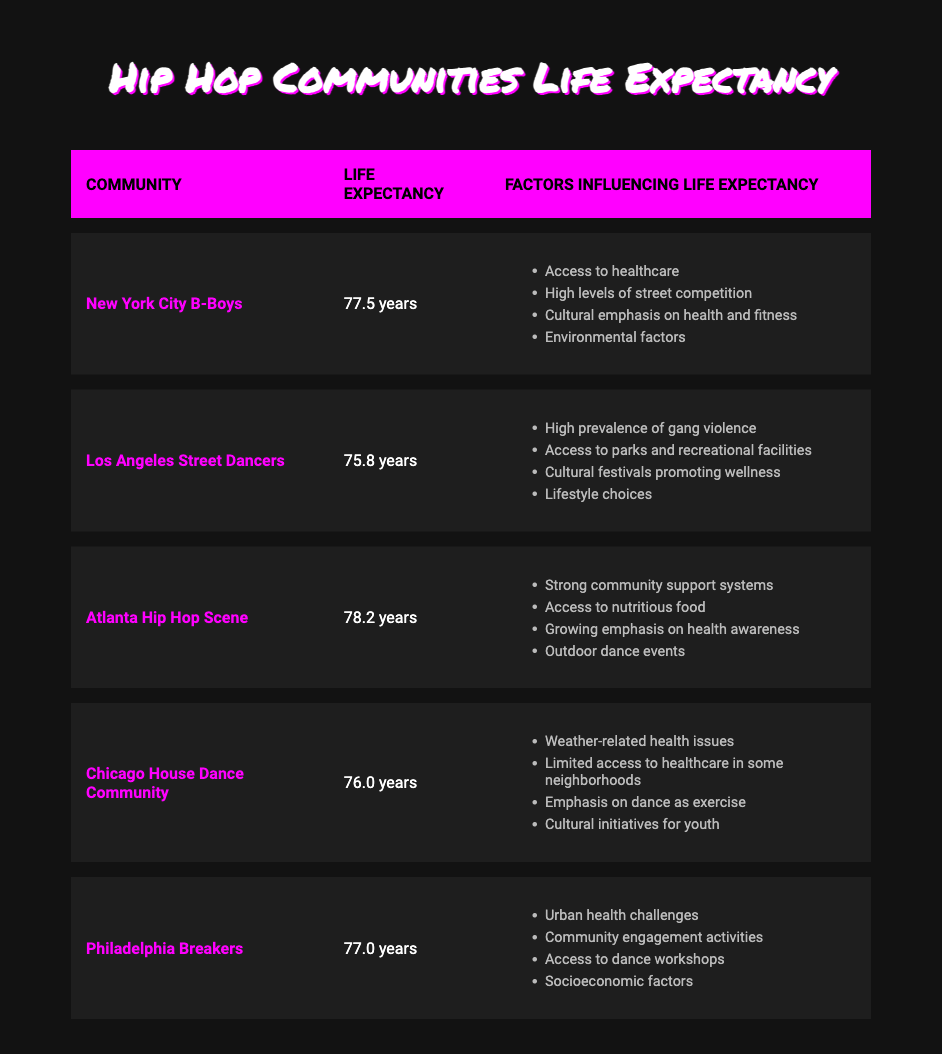What is the life expectancy of the Atlanta Hip Hop Scene? The table lists the life expectancy for the Atlanta Hip Hop Scene as 78.2 years.
Answer: 78.2 years Which community has the highest life expectancy? The highest life expectancy listed in the table is for the Atlanta Hip Hop Scene at 78.2 years.
Answer: Atlanta Hip Hop Scene What is the difference in life expectancy between New York City B-Boys and Los Angeles Street Dancers? The life expectancy of New York City B-Boys is 77.5 years and that of Los Angeles Street Dancers is 75.8 years. The difference is calculated as 77.5 - 75.8 = 1.7 years.
Answer: 1.7 years Is it true that the Chicago House Dance Community has a higher life expectancy than Los Angeles Street Dancers? The table shows that the life expectancy of the Chicago House Dance Community is 76.0 years, while Los Angeles Street Dancers have a life expectancy of 75.8 years. Therefore, it is true that Chicago House Dancers have a higher life expectancy.
Answer: Yes Which community has factors related to "Access to healthcare"? The New York City B-Boys and the Chicago House Dance Community have "Access to healthcare" as one of their factors influencing life expectancy.
Answer: New York City B-Boys, Chicago House Dance Community What is the average life expectancy of the communities listed in the table? The life expectancies are 77.5, 75.8, 78.2, 76.0, and 77.0. Summing these gives 384.5 years. Dividing by the number of communities (5) yields an average of 384.5 / 5 = 76.9 years.
Answer: 76.9 years Are there any communities that emphasize dance as part of their cultural support systems? Yes, both the New York City B-Boys and the Chicago House Dance Community emphasize dance as part of their cultural support systems.
Answer: Yes Which community experiences high levels of street competition? The New York City B-Boys experience high levels of street competition as indicated in the factors influencing their life expectancy.
Answer: New York City B-Boys 